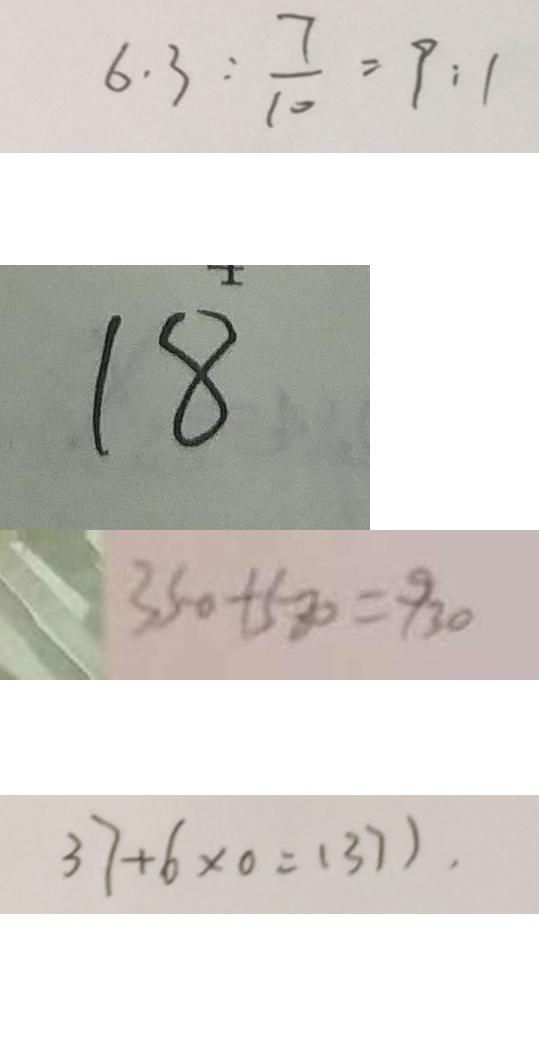Convert formula to latex. <formula><loc_0><loc_0><loc_500><loc_500>6 . 3 : \frac { 7 } { 1 0 } = 9 : 1 
 1 8 
 3 5 0 + 5 8 0 = 9 3 0 
 3 7 + 6 \times 0 = ( 3 7 ) .</formula> 